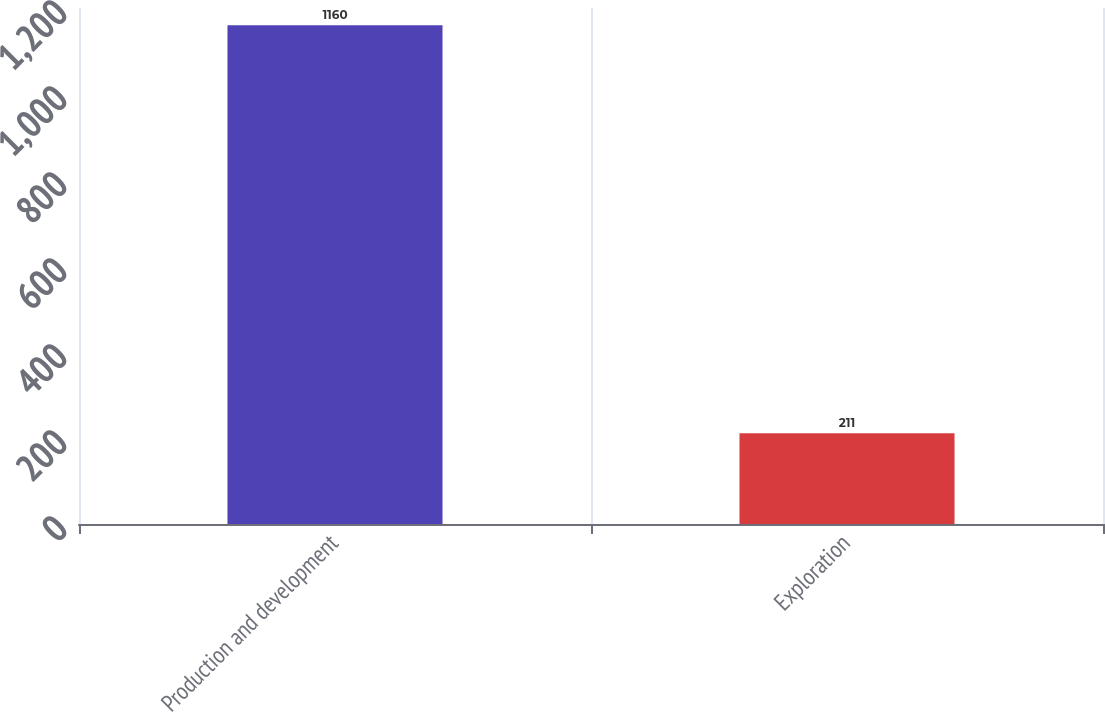<chart> <loc_0><loc_0><loc_500><loc_500><bar_chart><fcel>Production and development<fcel>Exploration<nl><fcel>1160<fcel>211<nl></chart> 